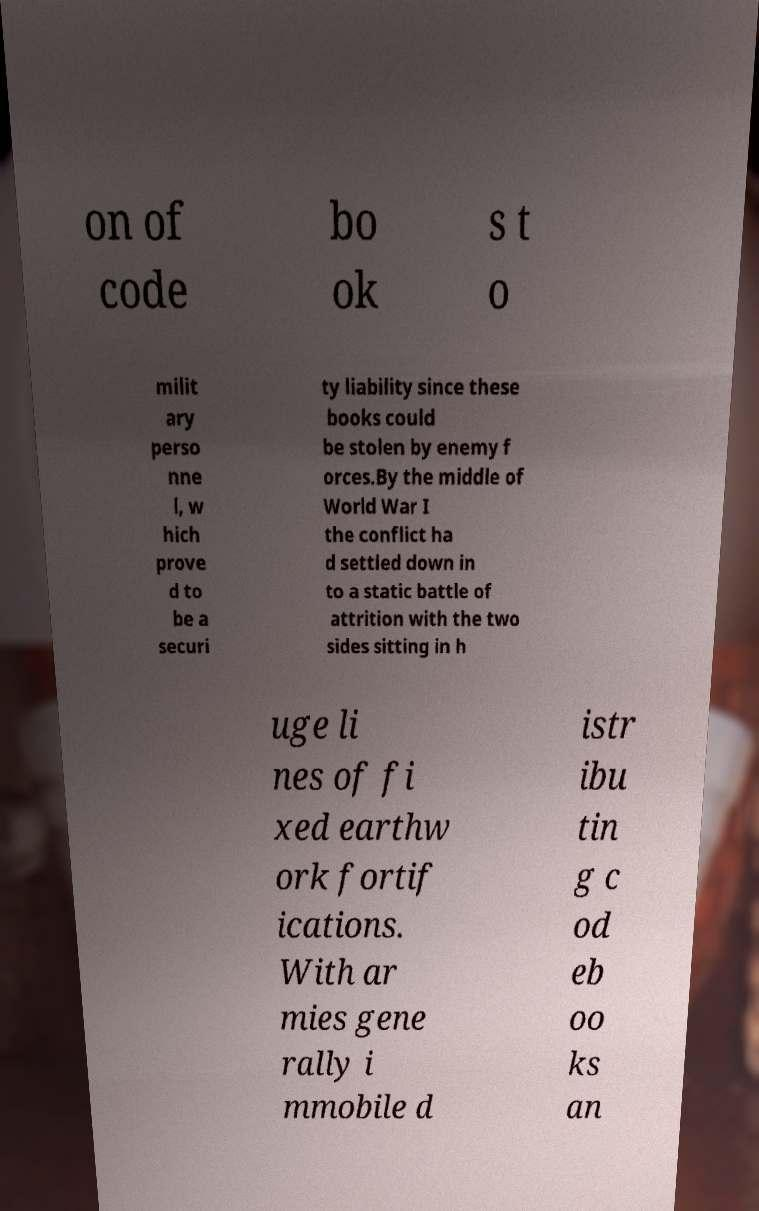Please read and relay the text visible in this image. What does it say? on of code bo ok s t o milit ary perso nne l, w hich prove d to be a securi ty liability since these books could be stolen by enemy f orces.By the middle of World War I the conflict ha d settled down in to a static battle of attrition with the two sides sitting in h uge li nes of fi xed earthw ork fortif ications. With ar mies gene rally i mmobile d istr ibu tin g c od eb oo ks an 